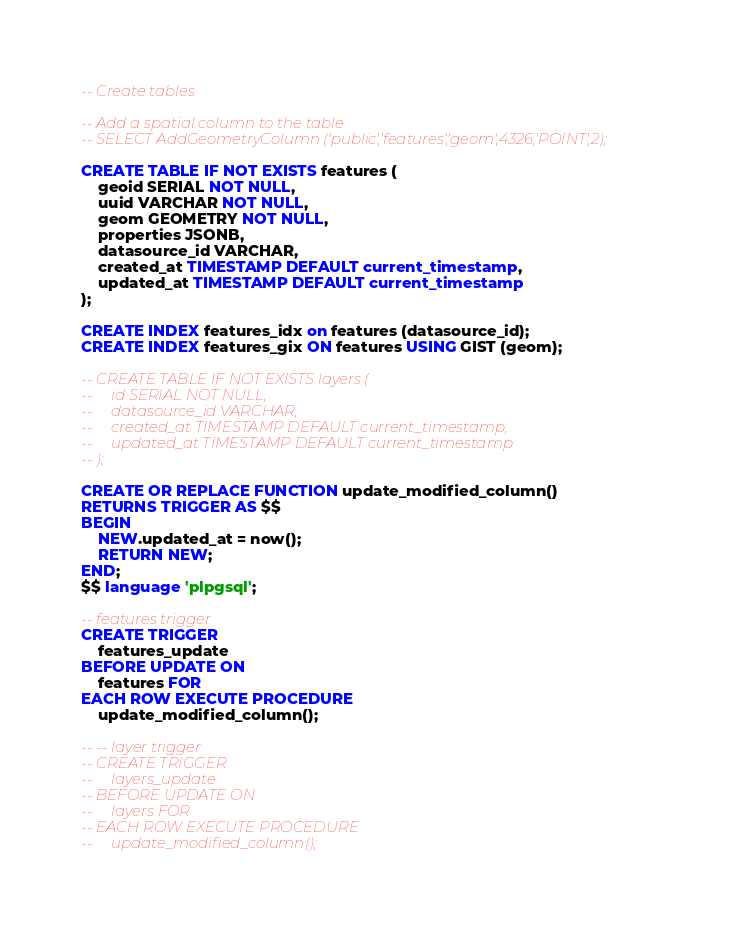<code> <loc_0><loc_0><loc_500><loc_500><_SQL_>-- Create tables

-- Add a spatial column to the table
-- SELECT AddGeometryColumn ('public','features','geom',4326,'POINT',2);

CREATE TABLE IF NOT EXISTS features (
    geoid SERIAL NOT NULL,
    uuid VARCHAR NOT NULL,
    geom GEOMETRY NOT NULL,
    properties JSONB,
    datasource_id VARCHAR,
    created_at TIMESTAMP DEFAULT current_timestamp,
    updated_at TIMESTAMP DEFAULT current_timestamp
);

CREATE INDEX features_idx on features (datasource_id);
CREATE INDEX features_gix ON features USING GIST (geom);

-- CREATE TABLE IF NOT EXISTS layers (
--     id SERIAL NOT NULL,
--     datasource_id VARCHAR,
--     created_at TIMESTAMP DEFAULT current_timestamp,
--     updated_at TIMESTAMP DEFAULT current_timestamp
-- );

CREATE OR REPLACE FUNCTION update_modified_column()
RETURNS TRIGGER AS $$
BEGIN
    NEW.updated_at = now();
    RETURN NEW;
END;
$$ language 'plpgsql';

-- features trigger
CREATE TRIGGER
    features_update
BEFORE UPDATE ON
    features FOR
EACH ROW EXECUTE PROCEDURE
    update_modified_column();

-- -- layer trigger
-- CREATE TRIGGER
--     layers_update
-- BEFORE UPDATE ON
--     layers FOR
-- EACH ROW EXECUTE PROCEDURE
--     update_modified_column();
</code> 